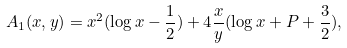<formula> <loc_0><loc_0><loc_500><loc_500>A _ { 1 } ( x , y ) = x ^ { 2 } ( \log x - \frac { 1 } { 2 } ) + 4 \frac { x } { y } ( \log x + P + \frac { 3 } { 2 } ) ,</formula> 